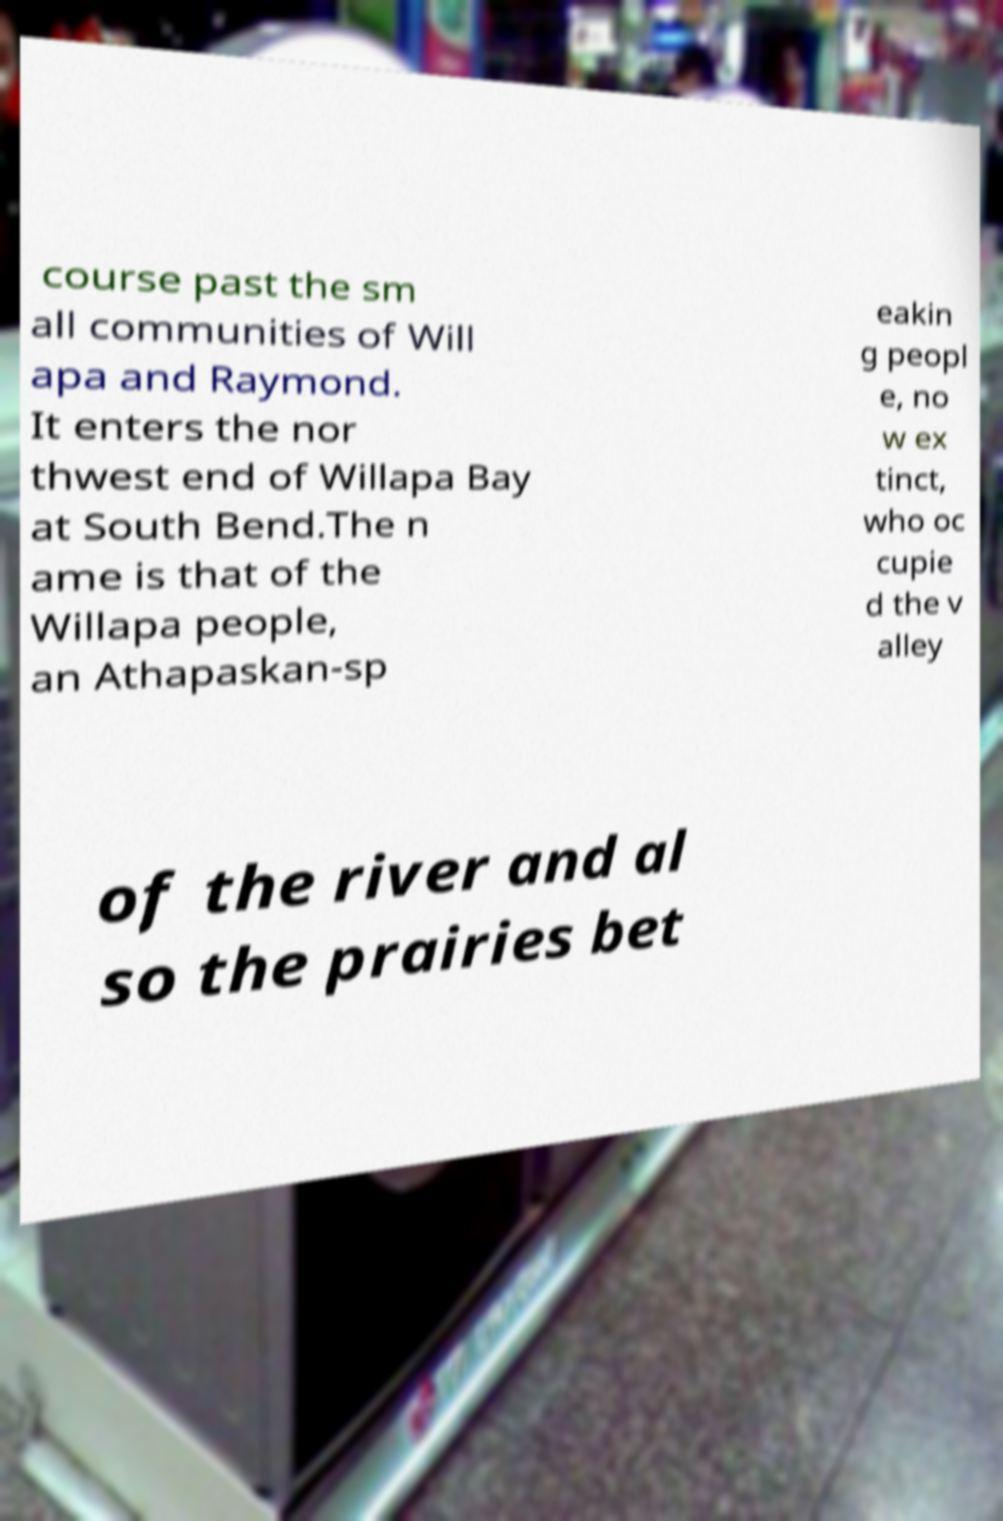Could you assist in decoding the text presented in this image and type it out clearly? course past the sm all communities of Will apa and Raymond. It enters the nor thwest end of Willapa Bay at South Bend.The n ame is that of the Willapa people, an Athapaskan-sp eakin g peopl e, no w ex tinct, who oc cupie d the v alley of the river and al so the prairies bet 